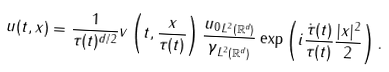Convert formula to latex. <formula><loc_0><loc_0><loc_500><loc_500>u ( t , x ) = \frac { 1 } { \tau ( t ) ^ { d / 2 } } v \left ( t , \frac { x } { \tau ( t ) } \right ) \frac { \| u _ { 0 } \| _ { L ^ { 2 } ( { \mathbb { R } } ^ { d } ) } } { \| \gamma \| _ { L ^ { 2 } ( { \mathbb { R } } ^ { d } ) } } \exp \left ( { i \frac { \dot { \tau } ( t ) } { \tau ( t ) } \frac { | x | ^ { 2 } } { 2 } } \right ) .</formula> 